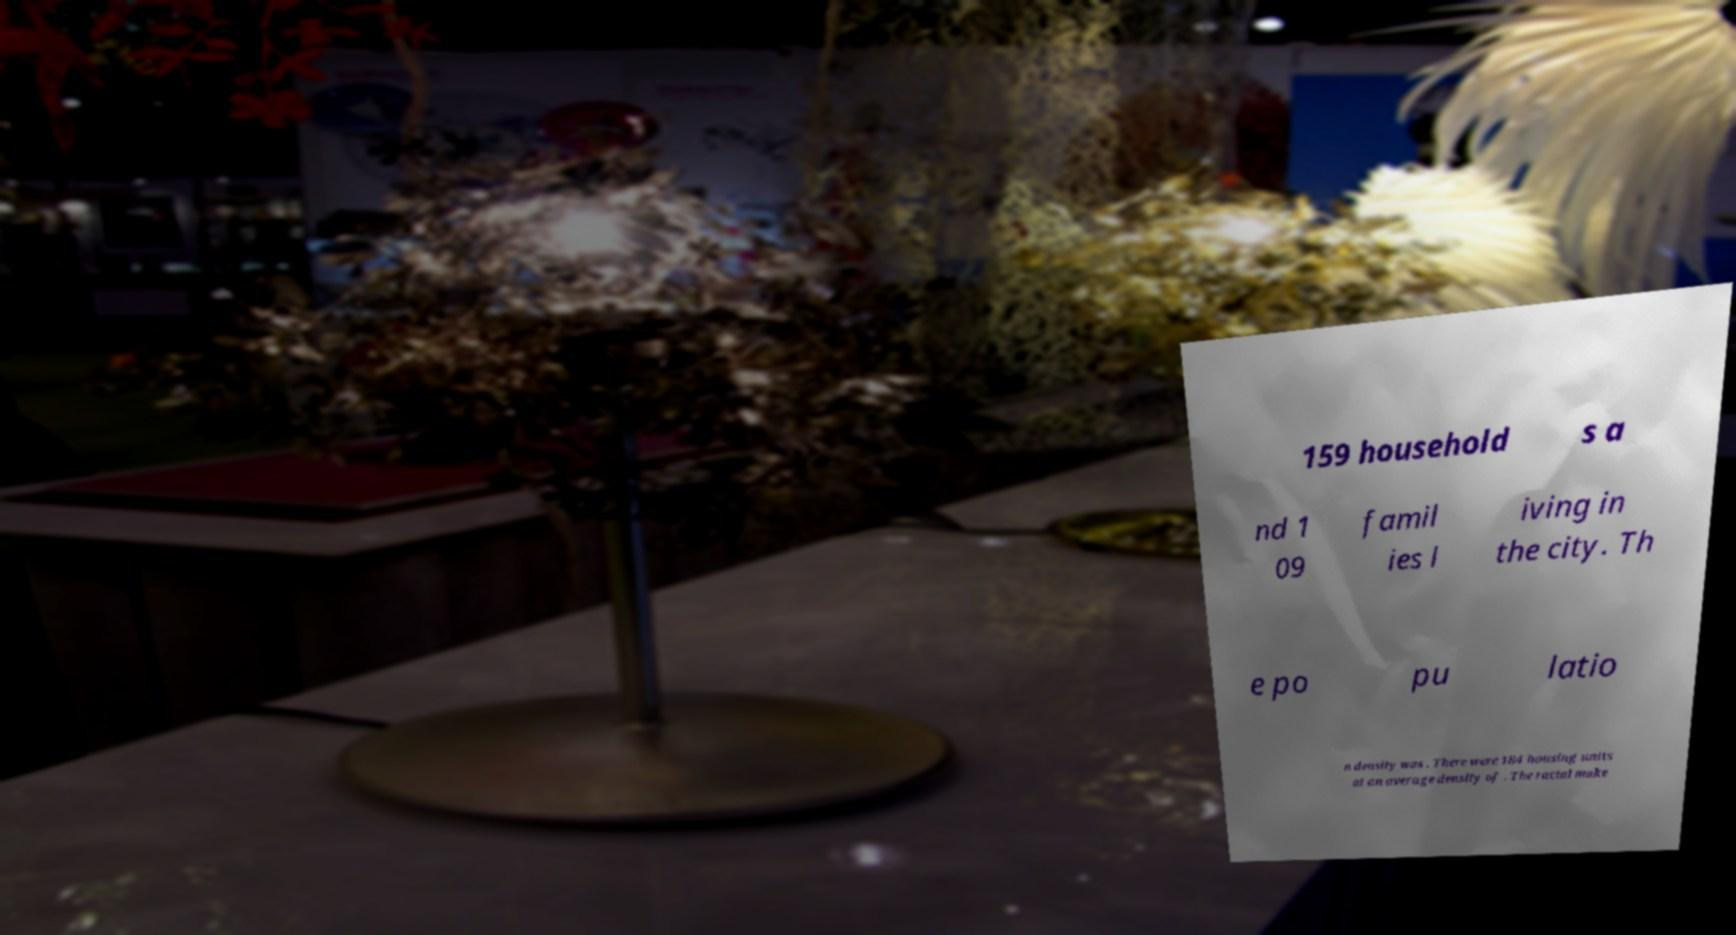Could you assist in decoding the text presented in this image and type it out clearly? 159 household s a nd 1 09 famil ies l iving in the city. Th e po pu latio n density was . There were 184 housing units at an average density of . The racial make 